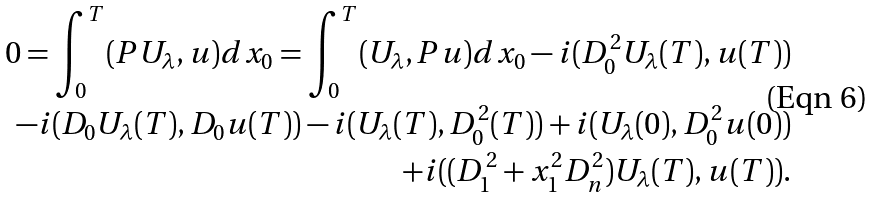Convert formula to latex. <formula><loc_0><loc_0><loc_500><loc_500>0 = \int _ { 0 } ^ { T } ( P U _ { \lambda } , u ) d x _ { 0 } = \int _ { 0 } ^ { T } ( U _ { \lambda } , P u ) d x _ { 0 } - i ( D _ { 0 } ^ { 2 } U _ { \lambda } ( T ) , u ( T ) ) \\ - i ( D _ { 0 } U _ { \lambda } ( T ) , D _ { 0 } u ( T ) ) - i ( U _ { \lambda } ( T ) , D _ { 0 } ^ { 2 } ( T ) ) + i ( U _ { \lambda } ( 0 ) , D _ { 0 } ^ { 2 } u ( 0 ) ) \\ + i ( ( D _ { 1 } ^ { 2 } + x _ { 1 } ^ { 2 } D _ { n } ^ { 2 } ) U _ { \lambda } ( T ) , u ( T ) ) .</formula> 